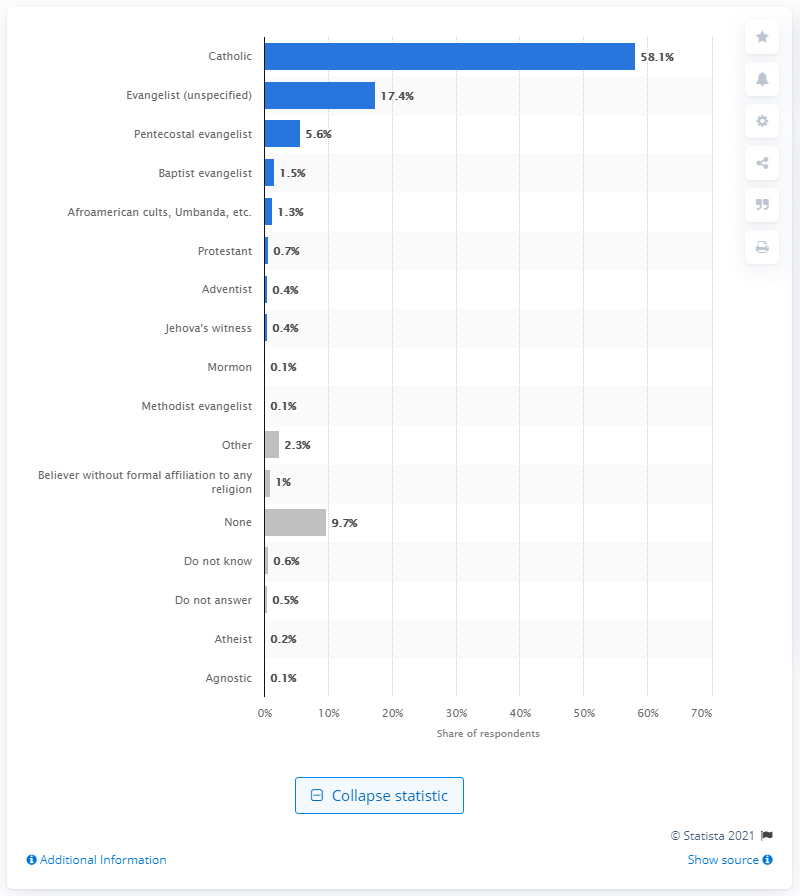Specify some key components in this picture. According to a survey, only 0.2% of Brazilians identified as atheists. 